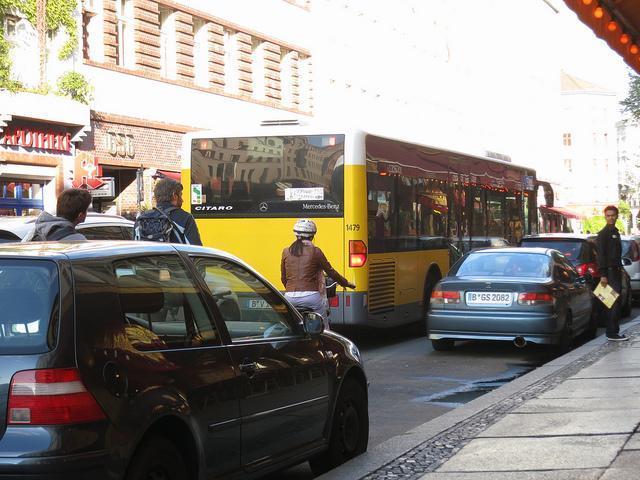How many people are not in a vehicle?
Give a very brief answer. 4. How many cars can be seen?
Give a very brief answer. 2. How many people are there?
Give a very brief answer. 3. How many drinks cups have straw?
Give a very brief answer. 0. 